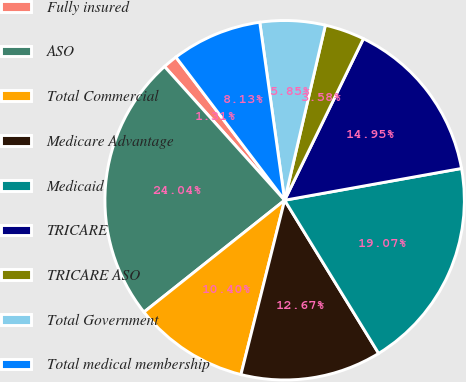Convert chart to OTSL. <chart><loc_0><loc_0><loc_500><loc_500><pie_chart><fcel>Fully insured<fcel>ASO<fcel>Total Commercial<fcel>Medicare Advantage<fcel>Medicaid<fcel>TRICARE<fcel>TRICARE ASO<fcel>Total Government<fcel>Total medical membership<nl><fcel>1.31%<fcel>24.04%<fcel>10.4%<fcel>12.67%<fcel>19.07%<fcel>14.95%<fcel>3.58%<fcel>5.85%<fcel>8.13%<nl></chart> 